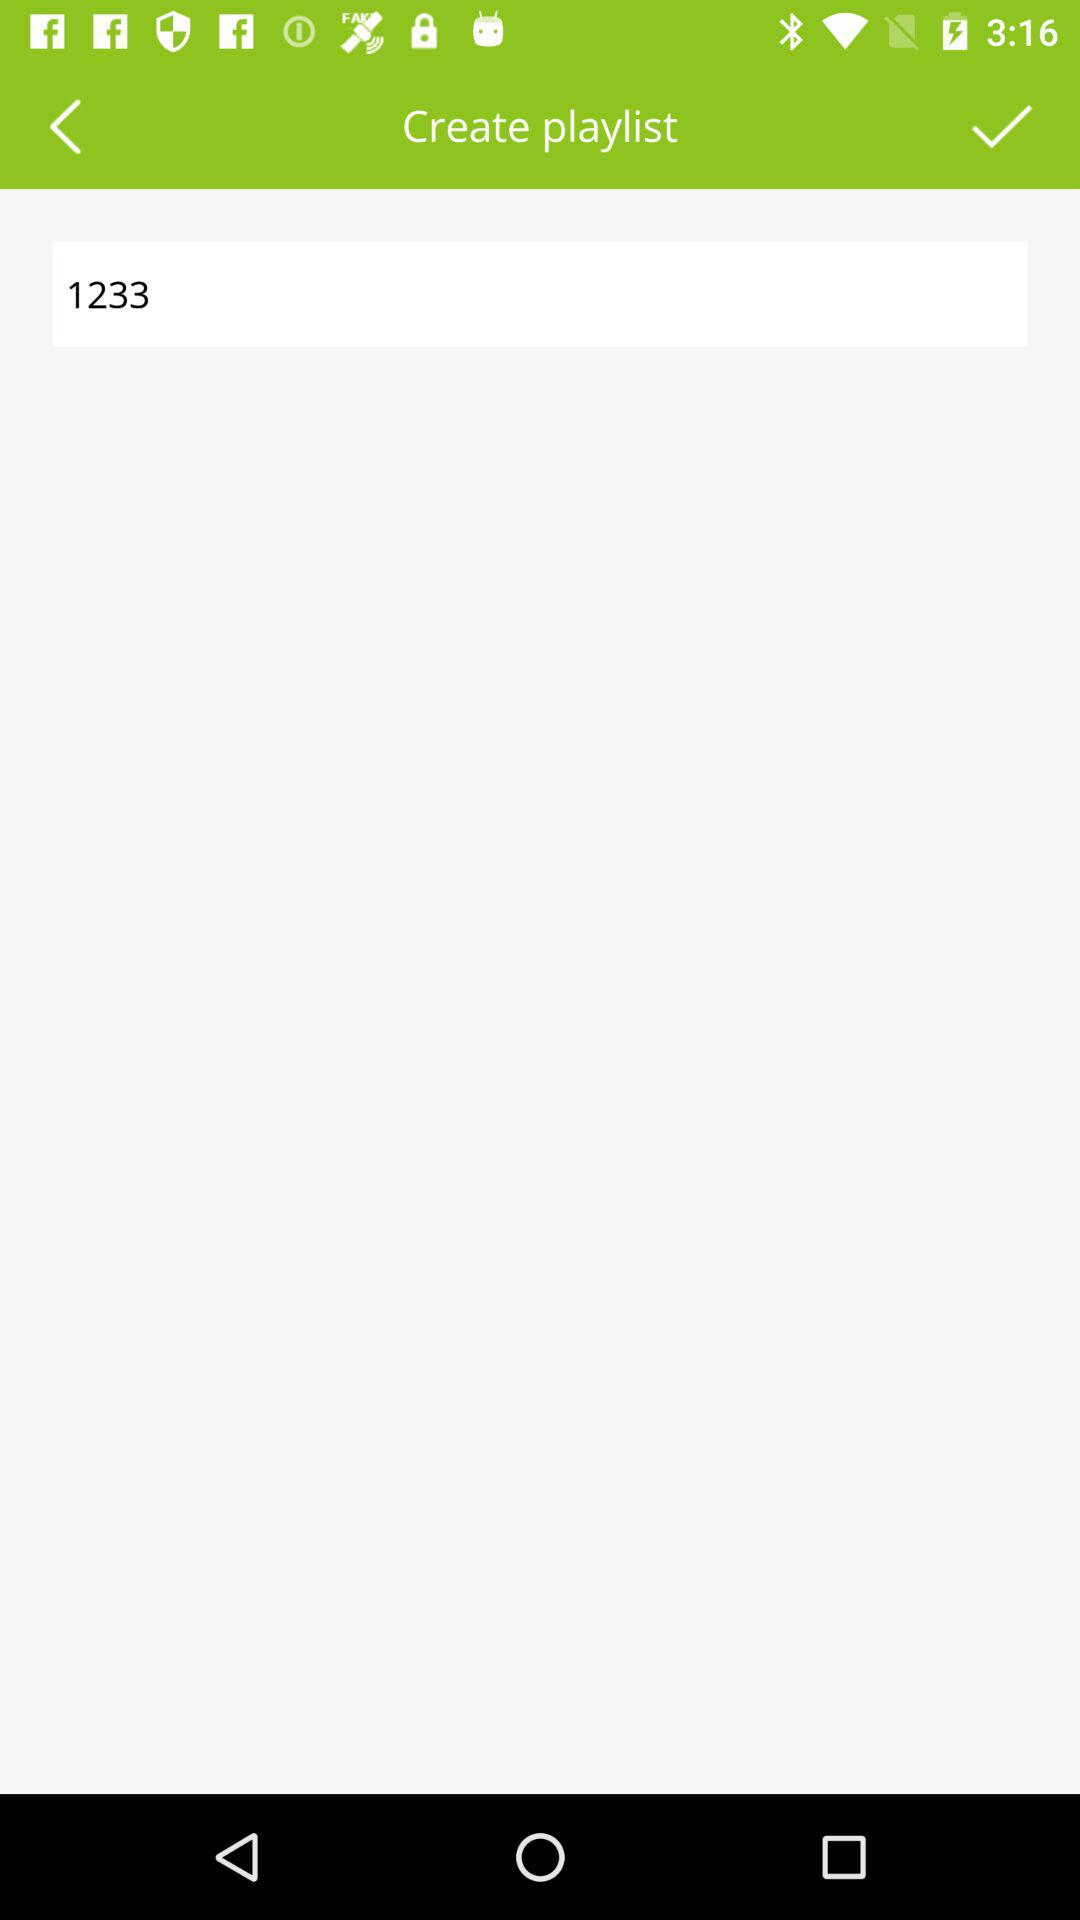What is the number in the search box? The number is 1233. 